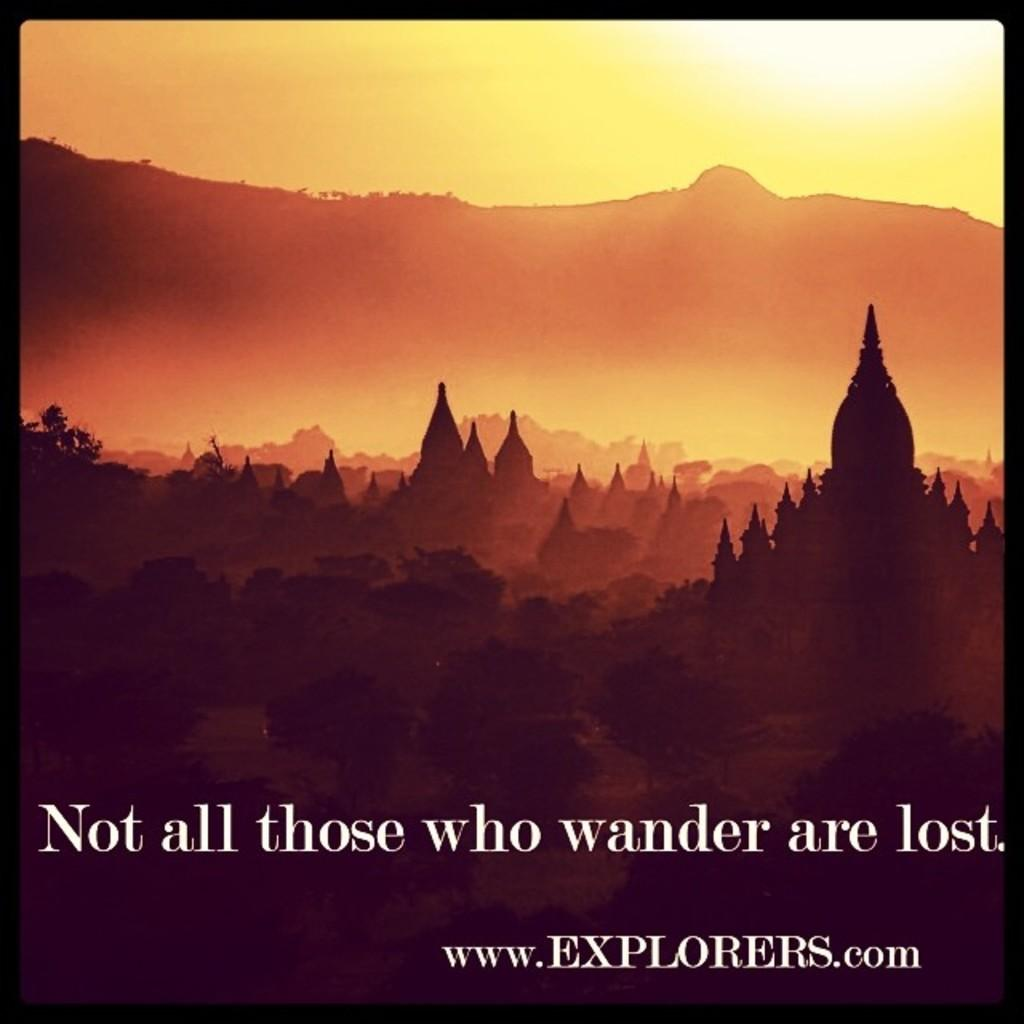<image>
Give a short and clear explanation of the subsequent image. A ad for explorers.com that contains a sunset over the mountains and a temple. 